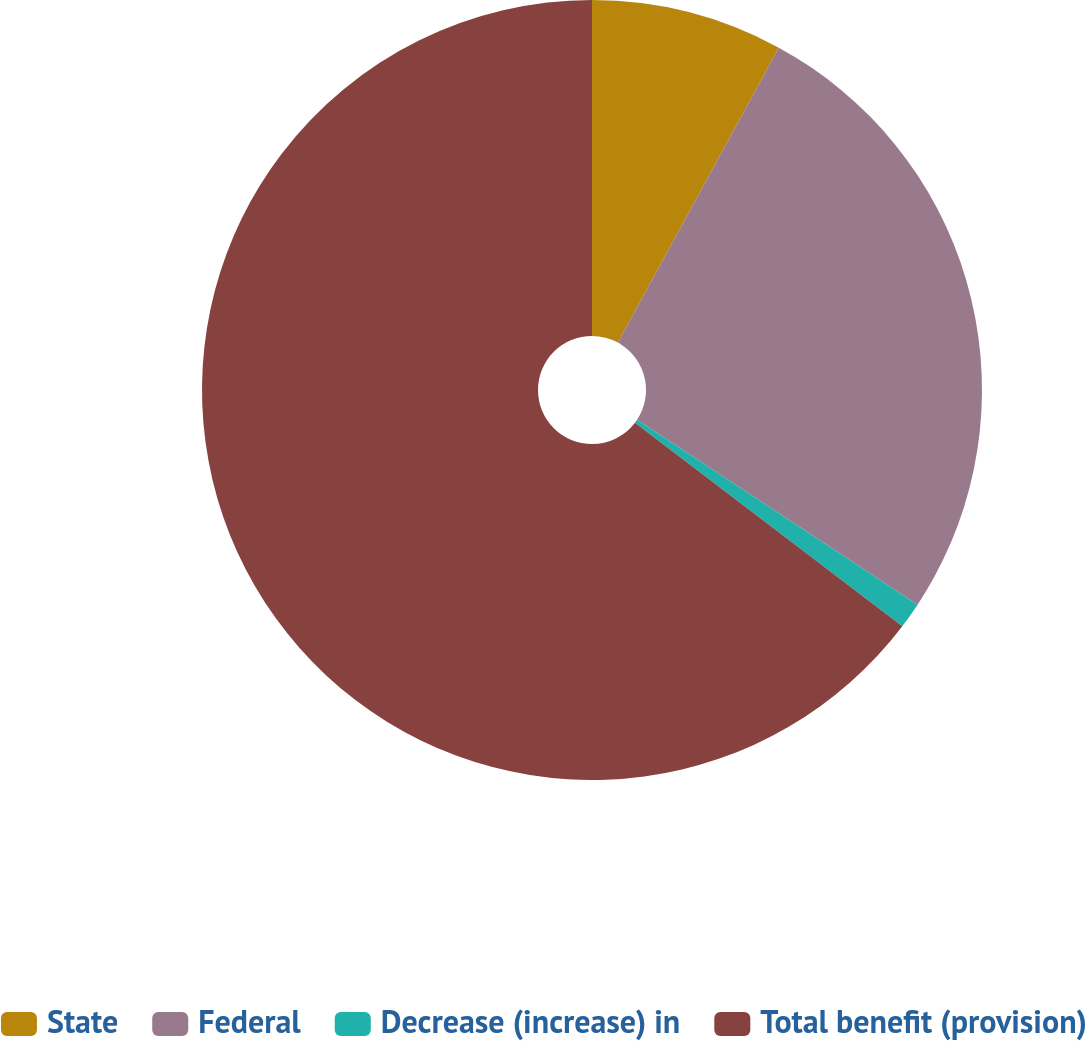Convert chart to OTSL. <chart><loc_0><loc_0><loc_500><loc_500><pie_chart><fcel>State<fcel>Federal<fcel>Decrease (increase) in<fcel>Total benefit (provision)<nl><fcel>7.95%<fcel>26.33%<fcel>1.08%<fcel>64.65%<nl></chart> 